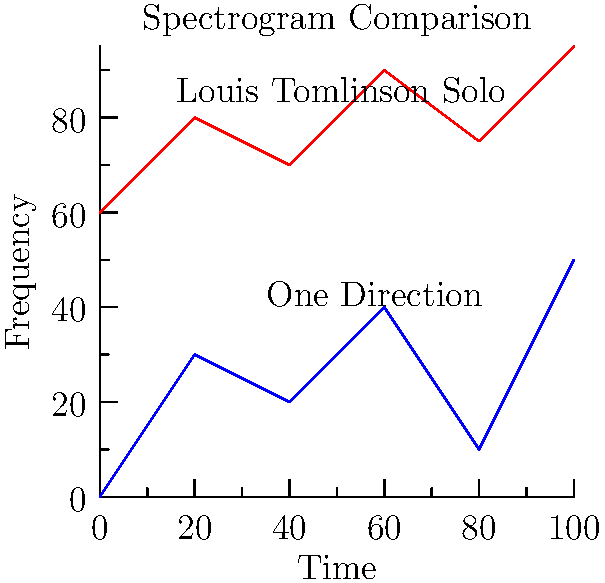Based on the simplified spectrogram comparison shown above, which characteristic would you most likely use to differentiate between Louis Tomlinson's solo songs and One Direction songs? To differentiate between Louis Tomlinson's solo songs and One Direction songs using spectrograms, we need to analyze the visual differences in the graph:

1. Frequency range: Louis Tomlinson's solo spectrogram (red) appears to occupy a higher frequency range compared to the One Direction spectrogram (blue).

2. Intensity: The solo spectrogram shows more consistent high-intensity patterns across frequencies, while the One Direction spectrogram has more variation.

3. Complexity: The solo spectrogram appears to have fewer fluctuations and a more consistent pattern, possibly indicating a simpler arrangement or fewer vocal harmonies.

4. Time-frequency distribution: The solo spectrogram maintains a more stable high-frequency content over time, while the One Direction spectrogram shows more variation across the time axis.

Given these observations, the most prominent and consistent difference is the overall frequency range occupied by each type of song. Louis Tomlinson's solo work tends to have more high-frequency content, which could be due to his individual vocal range, production style, or arrangement choices in his solo career.
Answer: Higher frequency range in Louis Tomlinson's solo songs 